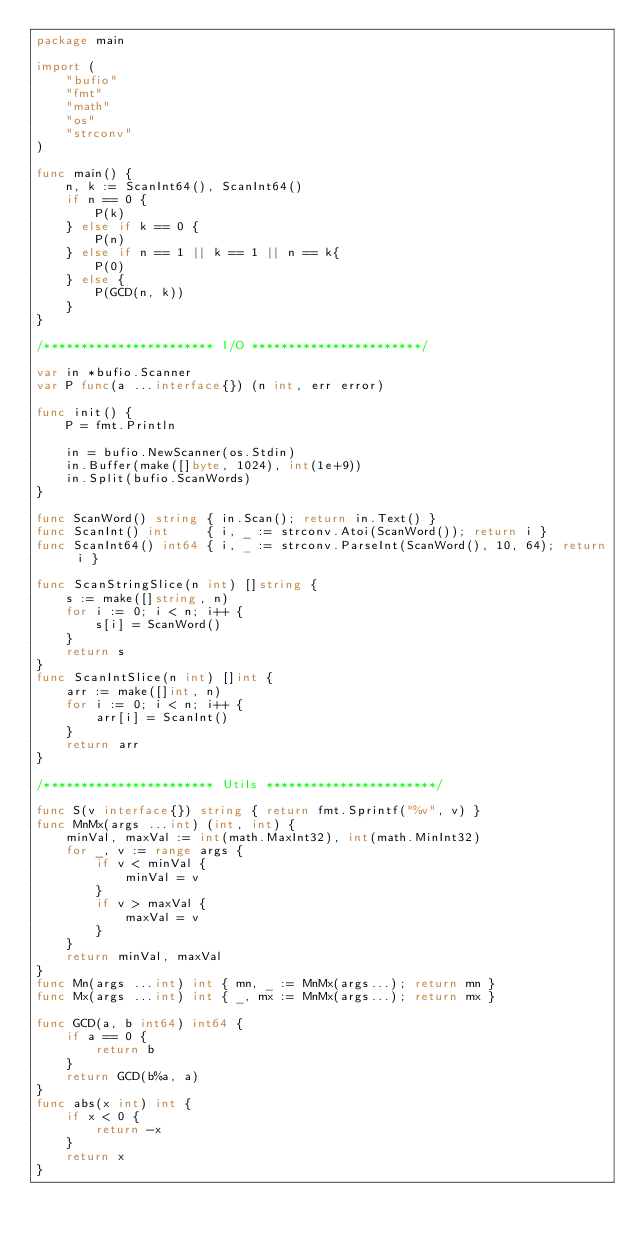Convert code to text. <code><loc_0><loc_0><loc_500><loc_500><_Go_>package main

import (
	"bufio"
	"fmt"
	"math"
	"os"
	"strconv"
)

func main() {
	n, k := ScanInt64(), ScanInt64()
	if n == 0 {
		P(k)
	} else if k == 0 {
		P(n)
	} else if n == 1 || k == 1 || n == k{
		P(0)
	} else {
		P(GCD(n, k))
	}
}

/*********************** I/O ***********************/

var in *bufio.Scanner
var P func(a ...interface{}) (n int, err error)

func init() {
	P = fmt.Println

	in = bufio.NewScanner(os.Stdin)
	in.Buffer(make([]byte, 1024), int(1e+9))
	in.Split(bufio.ScanWords)
}

func ScanWord() string { in.Scan(); return in.Text() }
func ScanInt() int     { i, _ := strconv.Atoi(ScanWord()); return i }
func ScanInt64() int64 { i, _ := strconv.ParseInt(ScanWord(), 10, 64); return i }

func ScanStringSlice(n int) []string {
	s := make([]string, n)
	for i := 0; i < n; i++ {
		s[i] = ScanWord()
	}
	return s
}
func ScanIntSlice(n int) []int {
	arr := make([]int, n)
	for i := 0; i < n; i++ {
		arr[i] = ScanInt()
	}
	return arr
}

/*********************** Utils ***********************/

func S(v interface{}) string { return fmt.Sprintf("%v", v) }
func MnMx(args ...int) (int, int) {
	minVal, maxVal := int(math.MaxInt32), int(math.MinInt32)
	for _, v := range args {
		if v < minVal {
			minVal = v
		}
		if v > maxVal {
			maxVal = v
		}
	}
	return minVal, maxVal
}
func Mn(args ...int) int { mn, _ := MnMx(args...); return mn }
func Mx(args ...int) int { _, mx := MnMx(args...); return mx }

func GCD(a, b int64) int64 {
	if a == 0 {
		return b
	}
	return GCD(b%a, a)
}
func abs(x int) int {
	if x < 0 {
		return -x
	}
	return x
}
</code> 